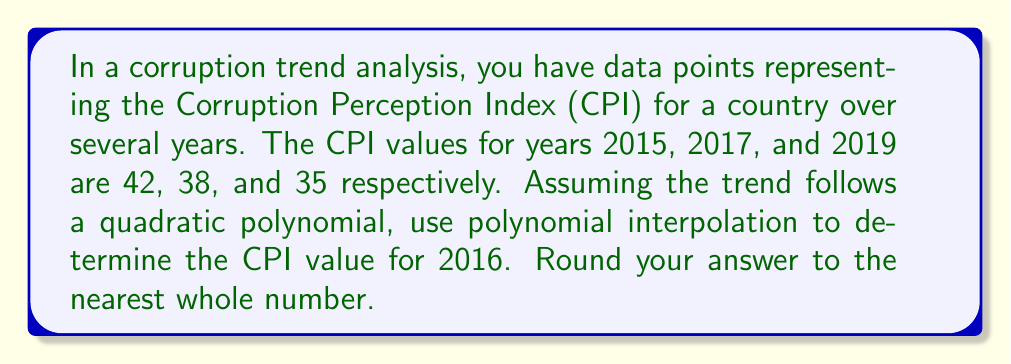Help me with this question. To solve this problem, we'll use Lagrange polynomial interpolation for a quadratic function. Let's follow these steps:

1) First, we'll assign variables:
   Let $x$ represent the year and $y$ represent the CPI.
   $(x_0, y_0) = (2015, 42)$
   $(x_1, y_1) = (2017, 38)$
   $(x_2, y_2) = (2019, 35)$

2) The Lagrange interpolation polynomial is given by:
   $$L(x) = y_0\frac{(x-x_1)(x-x_2)}{(x_0-x_1)(x_0-x_2)} + y_1\frac{(x-x_0)(x-x_2)}{(x_1-x_0)(x_1-x_2)} + y_2\frac{(x-x_0)(x-x_1)}{(x_2-x_0)(x_2-x_1)}$$

3) Substituting our values:
   $$L(x) = 42\frac{(x-2017)(x-2019)}{(2015-2017)(2015-2019)} + 38\frac{(x-2015)(x-2019)}{(2017-2015)(2017-2019)} + 35\frac{(x-2015)(x-2017)}{(2019-2015)(2019-2017)}$$

4) Simplify:
   $$L(x) = 42\frac{(x-2017)(x-2019)}{(-2)(-4)} + 38\frac{(x-2015)(x-2019)}{(2)(-2)} + 35\frac{(x-2015)(x-2017)}{(4)(2)}$$

5) To find the CPI for 2016, we need to calculate $L(2016)$:
   $$L(2016) = 42\frac{(2016-2017)(2016-2019)}{8} + 38\frac{(2016-2015)(2016-2019)}{-4} + 35\frac{(2016-2015)(2016-2017)}{8}$$

6) Evaluate:
   $$L(2016) = 42\frac{(-1)(-3)}{8} + 38\frac{(1)(-3)}{-4} + 35\frac{(1)(-1)}{8}$$
   $$L(2016) = 42\frac{3}{8} + 38\frac{3}{4} - 35\frac{1}{8}$$
   $$L(2016) = 15.75 + 28.5 - 4.375$$
   $$L(2016) = 39.875$$

7) Rounding to the nearest whole number:
   $L(2016) \approx 40$
Answer: 40 